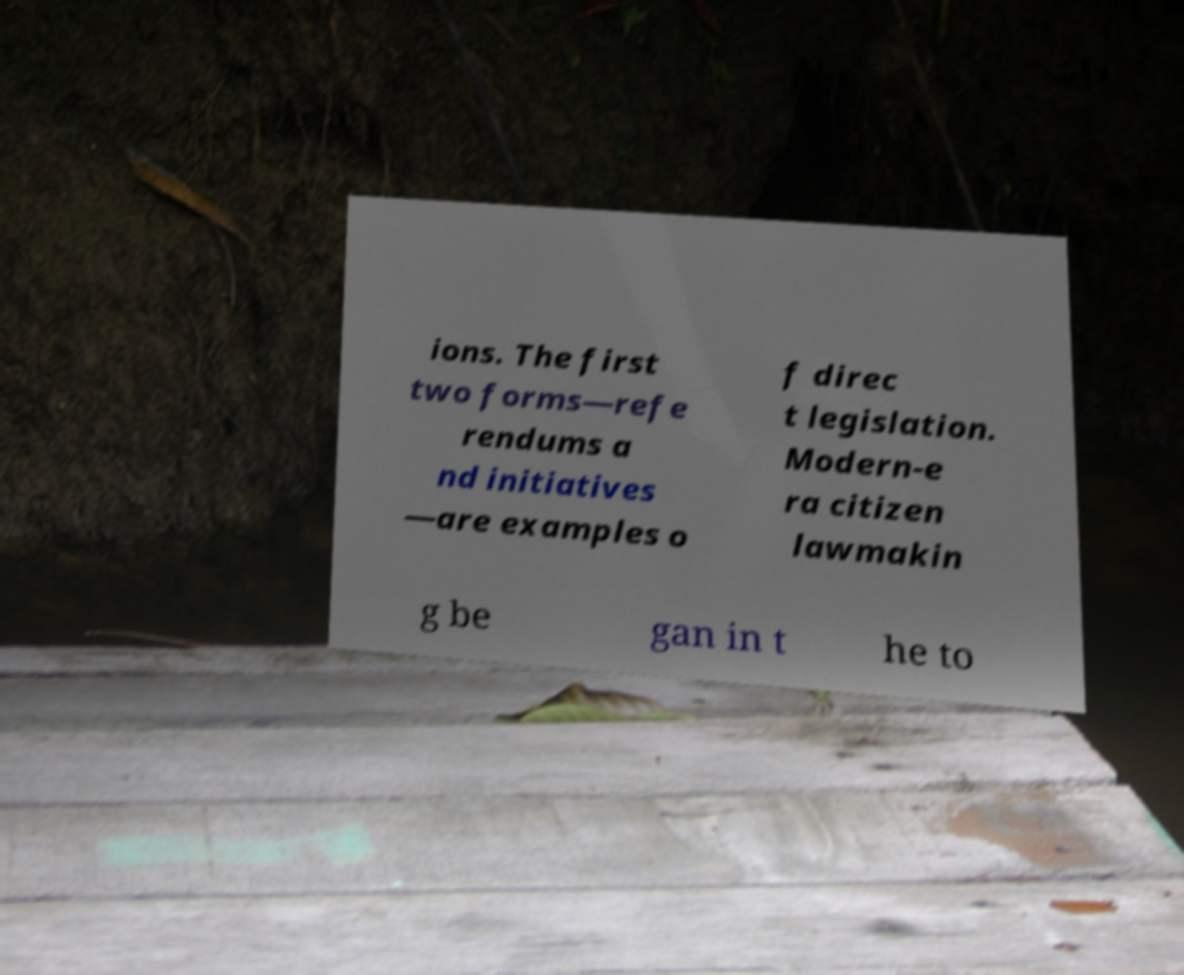Could you assist in decoding the text presented in this image and type it out clearly? ions. The first two forms—refe rendums a nd initiatives —are examples o f direc t legislation. Modern-e ra citizen lawmakin g be gan in t he to 